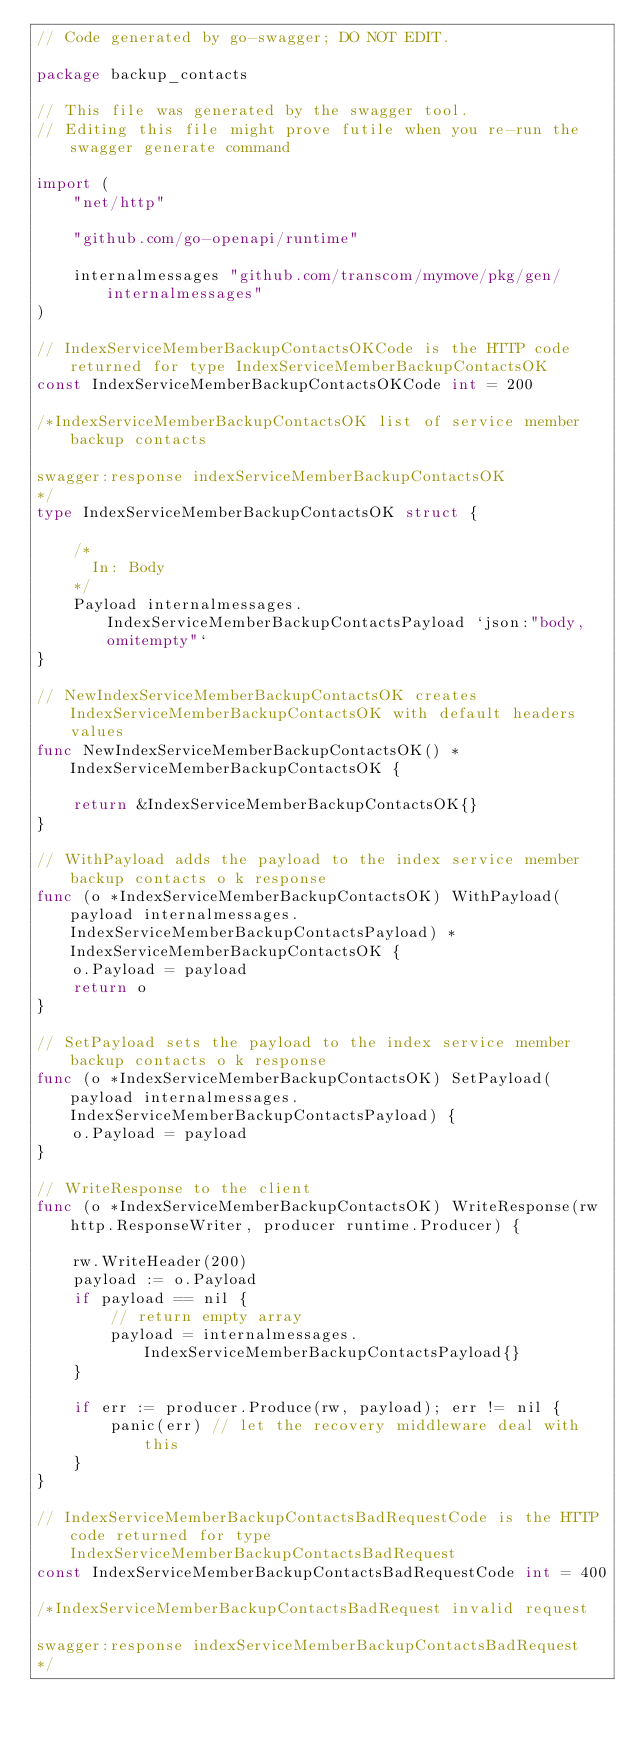<code> <loc_0><loc_0><loc_500><loc_500><_Go_>// Code generated by go-swagger; DO NOT EDIT.

package backup_contacts

// This file was generated by the swagger tool.
// Editing this file might prove futile when you re-run the swagger generate command

import (
	"net/http"

	"github.com/go-openapi/runtime"

	internalmessages "github.com/transcom/mymove/pkg/gen/internalmessages"
)

// IndexServiceMemberBackupContactsOKCode is the HTTP code returned for type IndexServiceMemberBackupContactsOK
const IndexServiceMemberBackupContactsOKCode int = 200

/*IndexServiceMemberBackupContactsOK list of service member backup contacts

swagger:response indexServiceMemberBackupContactsOK
*/
type IndexServiceMemberBackupContactsOK struct {

	/*
	  In: Body
	*/
	Payload internalmessages.IndexServiceMemberBackupContactsPayload `json:"body,omitempty"`
}

// NewIndexServiceMemberBackupContactsOK creates IndexServiceMemberBackupContactsOK with default headers values
func NewIndexServiceMemberBackupContactsOK() *IndexServiceMemberBackupContactsOK {

	return &IndexServiceMemberBackupContactsOK{}
}

// WithPayload adds the payload to the index service member backup contacts o k response
func (o *IndexServiceMemberBackupContactsOK) WithPayload(payload internalmessages.IndexServiceMemberBackupContactsPayload) *IndexServiceMemberBackupContactsOK {
	o.Payload = payload
	return o
}

// SetPayload sets the payload to the index service member backup contacts o k response
func (o *IndexServiceMemberBackupContactsOK) SetPayload(payload internalmessages.IndexServiceMemberBackupContactsPayload) {
	o.Payload = payload
}

// WriteResponse to the client
func (o *IndexServiceMemberBackupContactsOK) WriteResponse(rw http.ResponseWriter, producer runtime.Producer) {

	rw.WriteHeader(200)
	payload := o.Payload
	if payload == nil {
		// return empty array
		payload = internalmessages.IndexServiceMemberBackupContactsPayload{}
	}

	if err := producer.Produce(rw, payload); err != nil {
		panic(err) // let the recovery middleware deal with this
	}
}

// IndexServiceMemberBackupContactsBadRequestCode is the HTTP code returned for type IndexServiceMemberBackupContactsBadRequest
const IndexServiceMemberBackupContactsBadRequestCode int = 400

/*IndexServiceMemberBackupContactsBadRequest invalid request

swagger:response indexServiceMemberBackupContactsBadRequest
*/</code> 